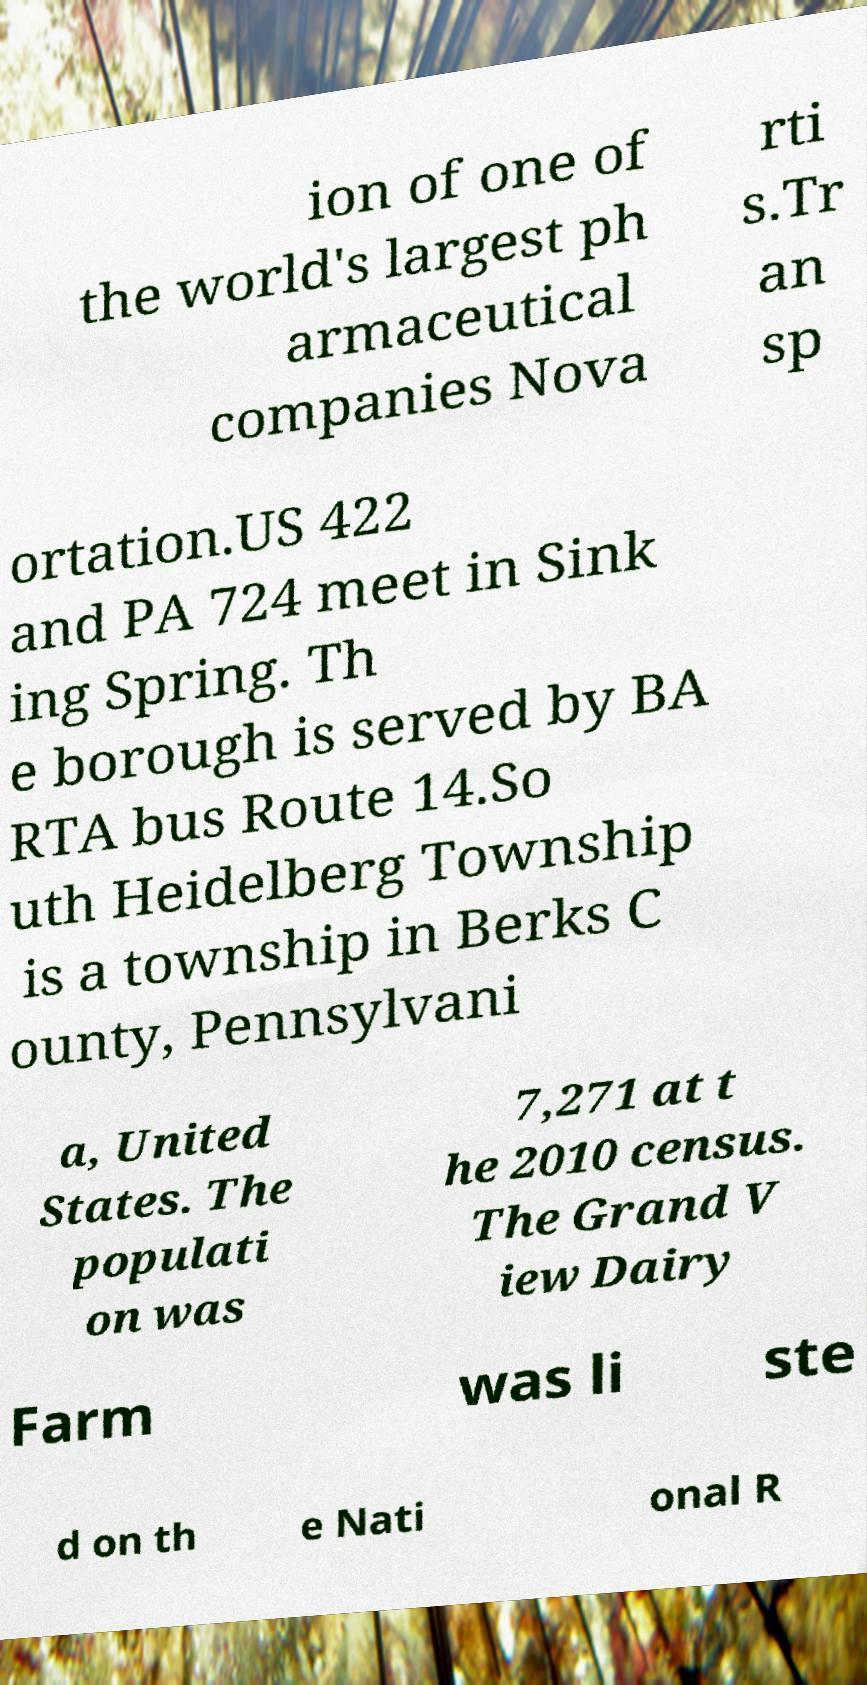Can you read and provide the text displayed in the image?This photo seems to have some interesting text. Can you extract and type it out for me? ion of one of the world's largest ph armaceutical companies Nova rti s.Tr an sp ortation.US 422 and PA 724 meet in Sink ing Spring. Th e borough is served by BA RTA bus Route 14.So uth Heidelberg Township is a township in Berks C ounty, Pennsylvani a, United States. The populati on was 7,271 at t he 2010 census. The Grand V iew Dairy Farm was li ste d on th e Nati onal R 